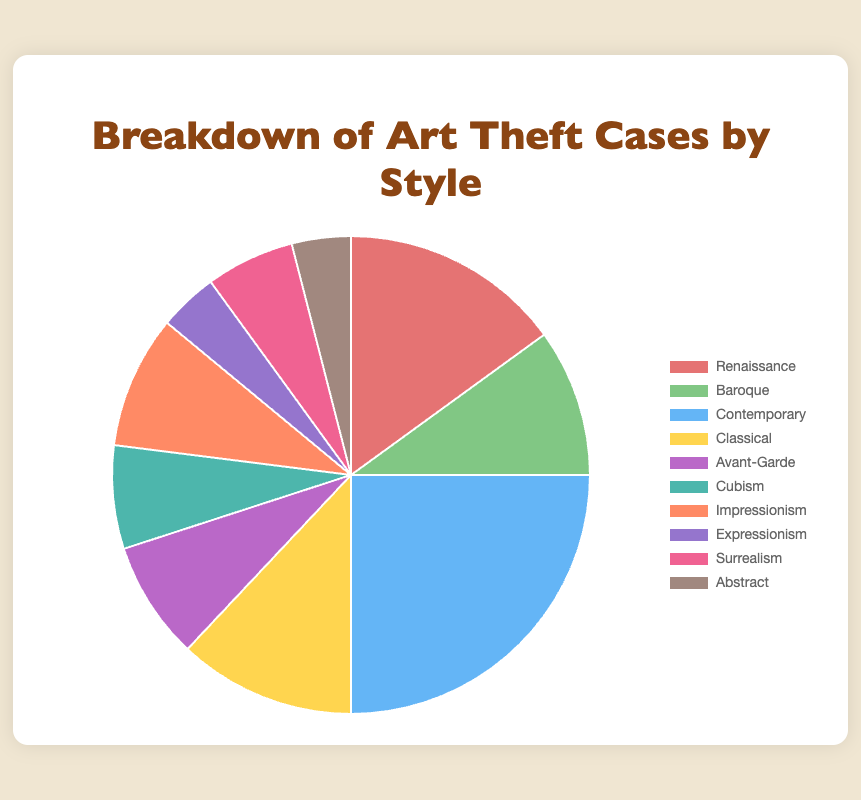What's the percentage of Contemporary art theft cases? To find the percentage of Contemporary art theft cases: 
1. Note the number of Contemporary cases is 25.
2. Sum all cases: 15 + 10 + 25 + 12 + 8 + 7 + 9 + 4 + 6 + 4 = 100.
3. Calculate \( \frac{25}{100} \times 100\% = 25\%\).
Answer: 25% Which art style has the least number of theft cases? Observe the numbers and find the smallest value: 
1. Compare each case.
2. Expressionism and Abstract both have 4 cases.
3. They are the lowest values.
Answer: Expressionism and Abstract What is the total number of art theft cases for Renaissance, Baroque, and Classical styles combined? To find the combined total:
1. Renaissance = 15, Baroque = 10, Classical = 12.
2. Sum them: 15 + 10 + 12 = 37.
Answer: 37 How many more Contemporary art theft cases are there compared to Avant-Garde? To find the difference:
1. Contemporary cases = 25.
2. Avant-Garde cases = 8.
3. Calculate 25 - 8 = 17.
Answer: 17 Which art style has a higher number of theft cases: Impressionism or Surrealism? Compare the numbers:
1. Impressionism = 9.
2. Surrealism = 6.
3. Impressionism has more cases.
Answer: Impressionism What is the ratio of Baroque to Renaissance art theft cases? To find the ratio:
1. Baroque = 10.
2. Renaissance = 15.
3. Calculate the ratio \( \frac{10}{15} = \frac{2}{3} \).
Answer: 2:3 Estimate the total percentage of theft cases for Renaissance, Baroque, and Classical together. To estimate the percentage:
1. Total cases = 100.
2. Combined cases for Renaissance, Baroque, and Classical = 37.
3. Calculate \( \frac{37}{100} \times 100\% = 37\% \).
Answer: 37% How does the number of Abstract cases compare visually to Renaissance cases? Analyze size differences:
1. Abstract has 4 cases.
2. Renaissance has 15 cases.
3. The Abstract slice is significantly smaller than Renaissance.
Answer: Much smaller Which category represents the art style with a mid-level frequency of theft, visually located near the center of frequency? Visually and mathematically:
1. List the cases in order: 4, 4, 6, 7, 8, 9, 10, 12, 15, 25.
2. Mid-level cases (median): 7, 8, 9, 10.
3. Center is Cubism with 7 cases.
Answer: Cubism 